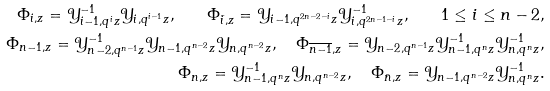Convert formula to latex. <formula><loc_0><loc_0><loc_500><loc_500>\Phi _ { i , z } = \mathcal { Y } _ { i - 1 , q ^ { i } z } ^ { - 1 } \mathcal { Y } _ { i , q ^ { i - 1 } z } , \quad \Phi _ { \bar { i } , z } = \mathcal { Y } _ { i - 1 , q ^ { 2 n - 2 - i } z } \mathcal { Y } _ { i , q ^ { 2 n - 1 - i } z } ^ { - 1 } , \quad 1 \leq i \leq n - 2 , \\ \Phi _ { n - 1 , z } = \mathcal { Y } _ { n - 2 , q ^ { n - 1 } z } ^ { - 1 } \mathcal { Y } _ { n - 1 , q ^ { n - 2 } z } \mathcal { Y } _ { n , q ^ { n - 2 } z } , \quad \Phi _ { \overline { n - 1 } , z } = \mathcal { Y } _ { n - 2 , q ^ { n - 1 } z } \mathcal { Y } _ { n - 1 , q ^ { n } z } ^ { - 1 } \mathcal { Y } _ { n , q ^ { n } z } ^ { - 1 } , \\ \Phi _ { n , z } = \mathcal { Y } _ { n - 1 , q ^ { n } z } ^ { - 1 } \mathcal { Y } _ { n , q ^ { n - 2 } z } , \quad \Phi _ { \bar { n } , z } = \mathcal { Y } _ { n - 1 , q ^ { n - 2 } z } \mathcal { Y } _ { n , q ^ { n } z } ^ { - 1 } .</formula> 